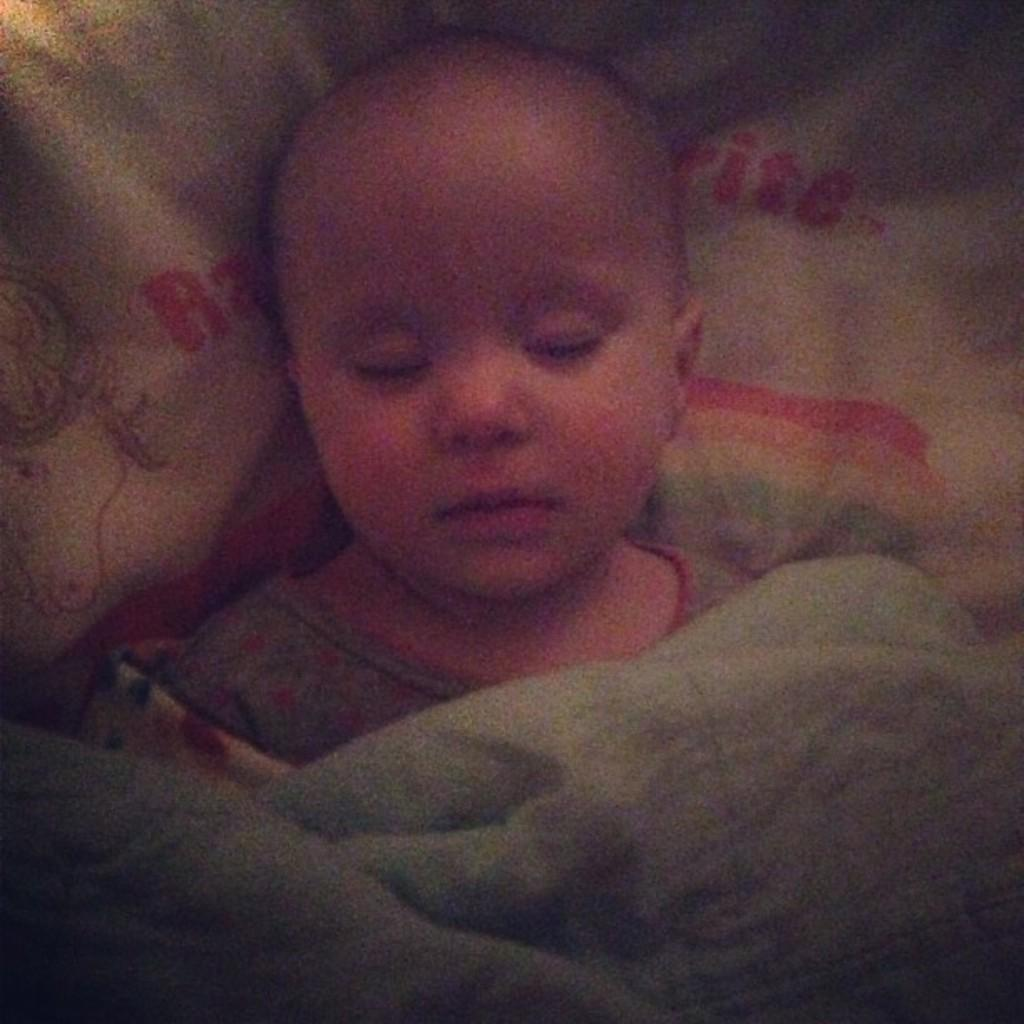What is the main subject of subject of the image? There is a baby in the image. What is the baby doing in the image? The baby is sleeping on a bed. What is located at the bottom of the image? There is a blanket at the bottom of the image. Where is the sofa located in the image? There is no sofa visible in the image. What type of toad can be seen interacting with the baby in the image? There is no toad present in the image; the baby is sleeping on a bed with a blanket. 